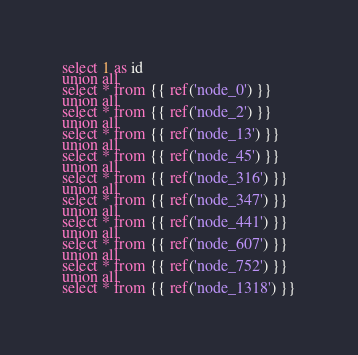<code> <loc_0><loc_0><loc_500><loc_500><_SQL_>select 1 as id
union all
select * from {{ ref('node_0') }}
union all
select * from {{ ref('node_2') }}
union all
select * from {{ ref('node_13') }}
union all
select * from {{ ref('node_45') }}
union all
select * from {{ ref('node_316') }}
union all
select * from {{ ref('node_347') }}
union all
select * from {{ ref('node_441') }}
union all
select * from {{ ref('node_607') }}
union all
select * from {{ ref('node_752') }}
union all
select * from {{ ref('node_1318') }}</code> 